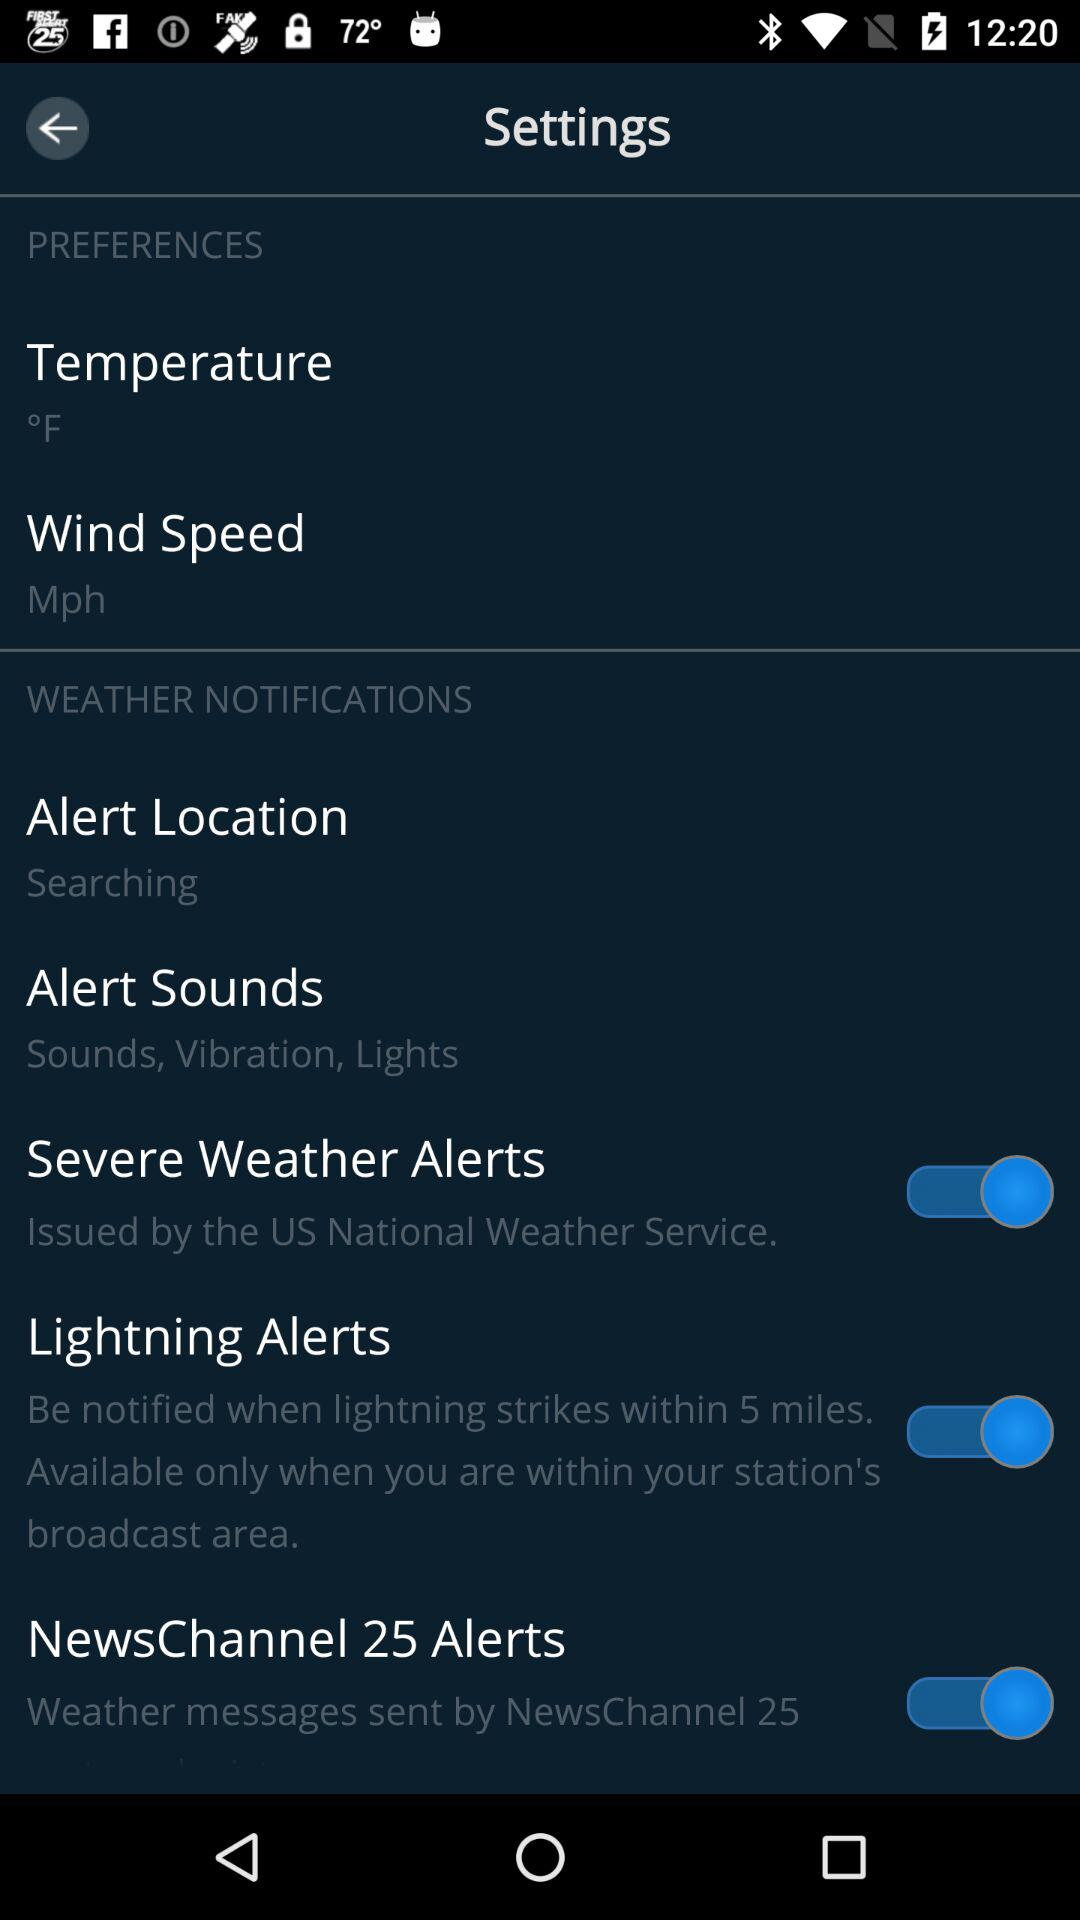What is the distance in miles within which "Lightning Alerts" will notify when lightning strikes? "Lightning Alerts" will notify when lightning strikes within 5 miles. 